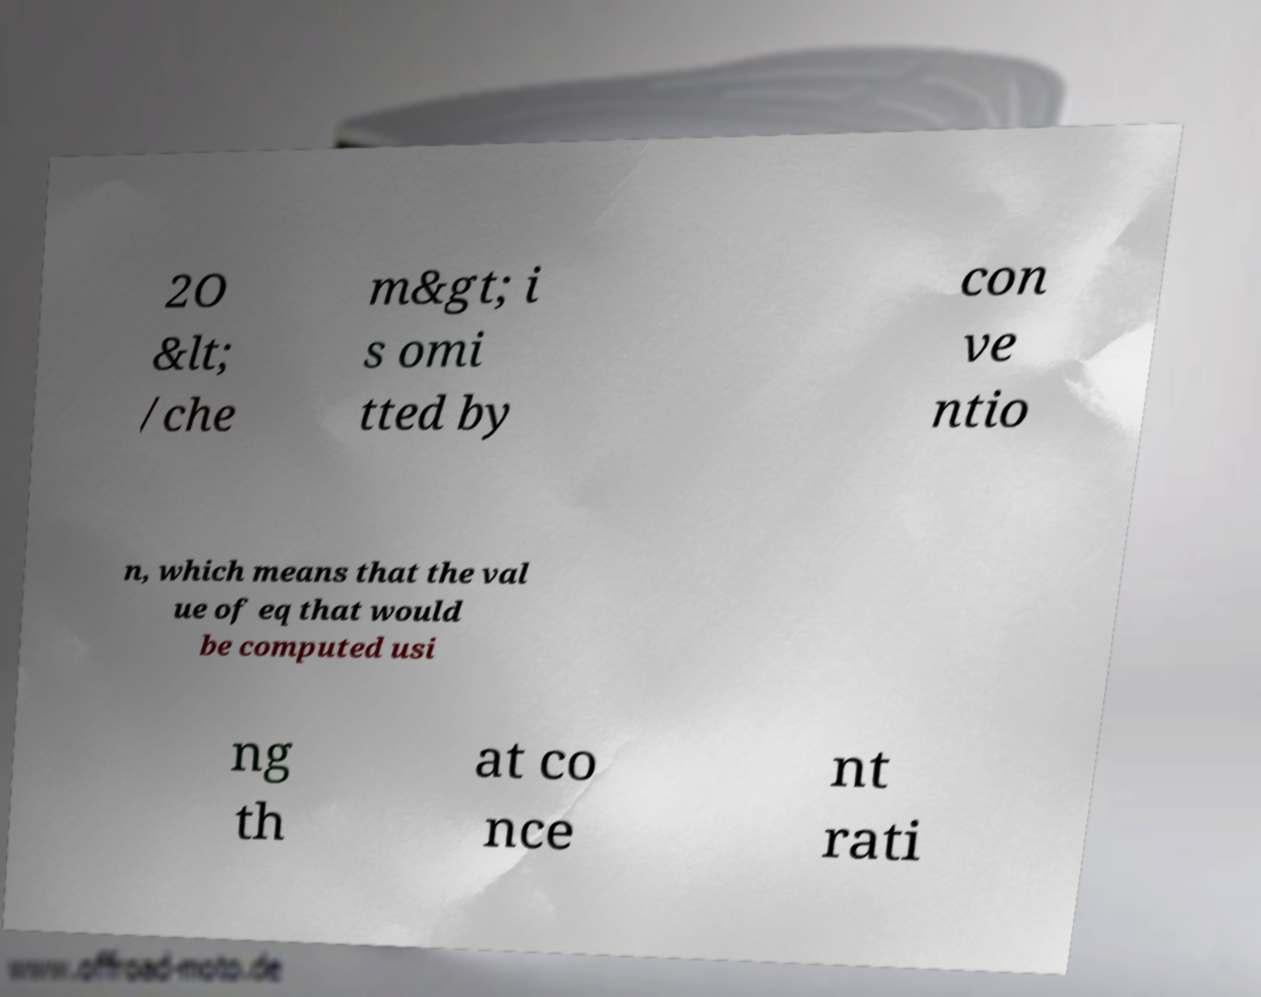I need the written content from this picture converted into text. Can you do that? 2O &lt; /che m&gt; i s omi tted by con ve ntio n, which means that the val ue of eq that would be computed usi ng th at co nce nt rati 